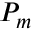<formula> <loc_0><loc_0><loc_500><loc_500>{ P _ { m } }</formula> 